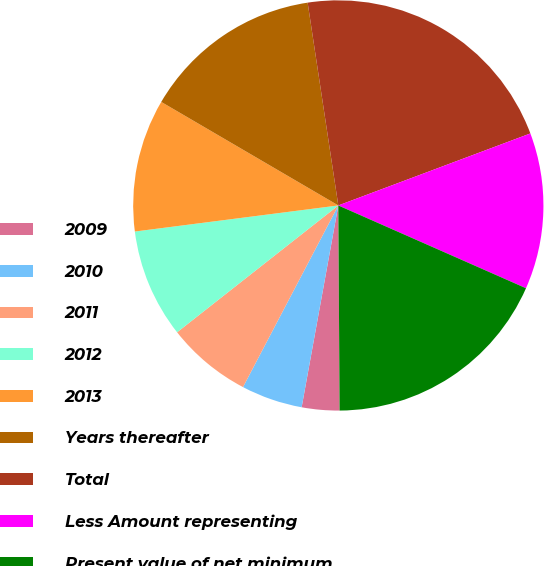Convert chart. <chart><loc_0><loc_0><loc_500><loc_500><pie_chart><fcel>2009<fcel>2010<fcel>2011<fcel>2012<fcel>2013<fcel>Years thereafter<fcel>Total<fcel>Less Amount representing<fcel>Present value of net minimum<nl><fcel>2.96%<fcel>4.83%<fcel>6.7%<fcel>8.58%<fcel>10.45%<fcel>14.19%<fcel>21.68%<fcel>12.32%<fcel>18.29%<nl></chart> 